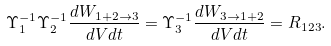<formula> <loc_0><loc_0><loc_500><loc_500>\Upsilon _ { 1 } ^ { - 1 } \Upsilon _ { 2 } ^ { - 1 } \frac { d W _ { 1 + 2 \rightarrow 3 } } { d V d t } = \Upsilon _ { 3 } ^ { - 1 } \frac { d W _ { 3 \rightarrow 1 + 2 } } { d V d t } = R _ { 1 2 3 } .</formula> 